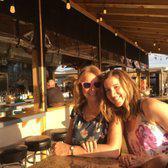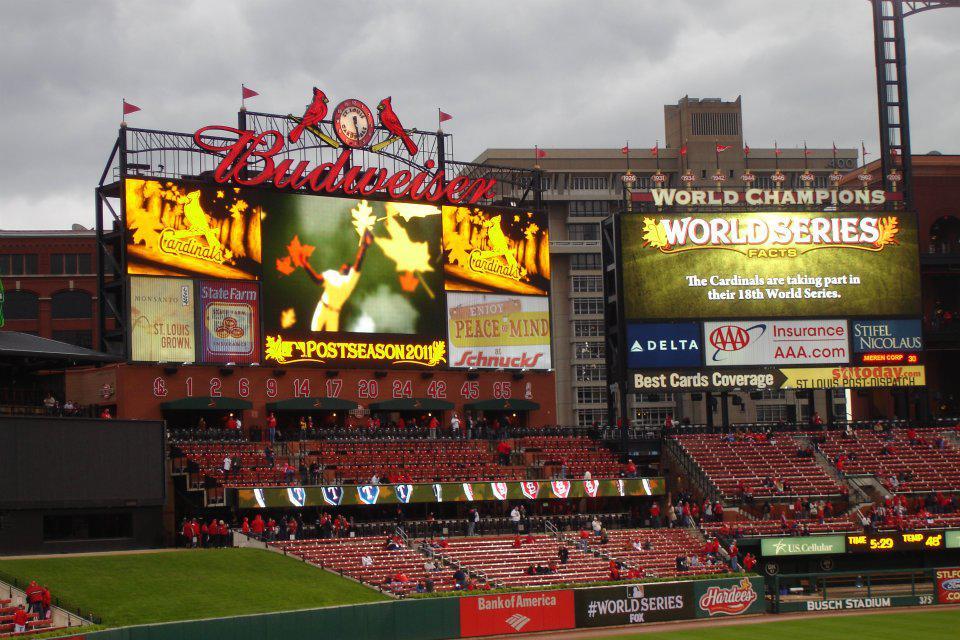The first image is the image on the left, the second image is the image on the right. Analyze the images presented: Is the assertion "One scoreboard is lit up with neon red and yellow colors." valid? Answer yes or no. Yes. The first image is the image on the left, the second image is the image on the right. Analyze the images presented: Is the assertion "One image shows two camera-facing smiling women posed side-by-side behind a table-like surface." valid? Answer yes or no. Yes. 